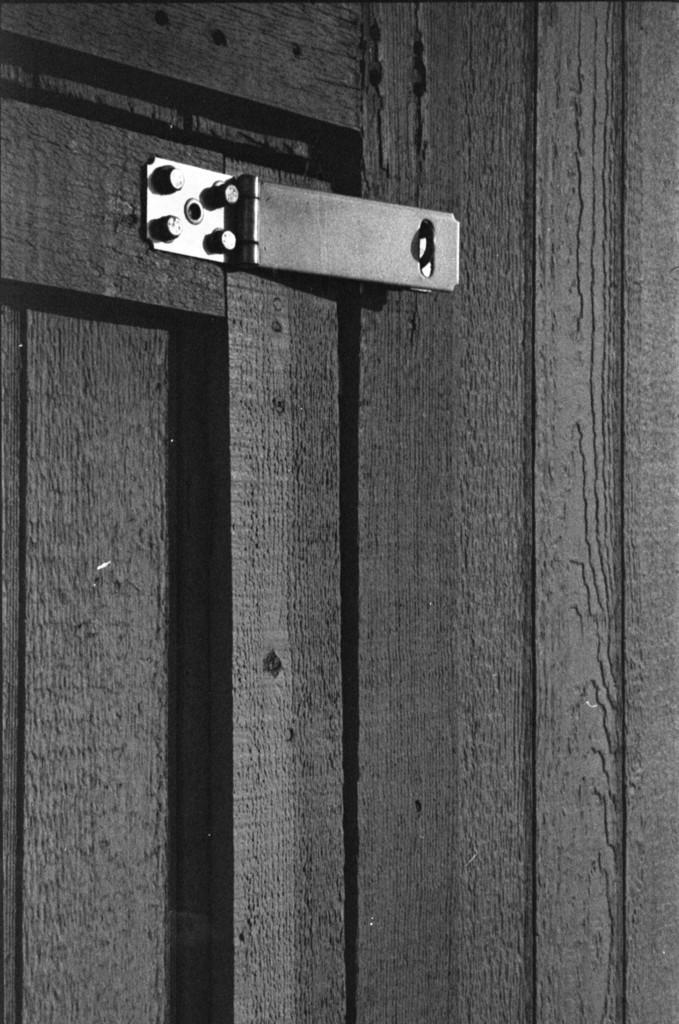Can you describe this image briefly? In this picture I can see the black door and wooden wall. At the top I can see the hook. 